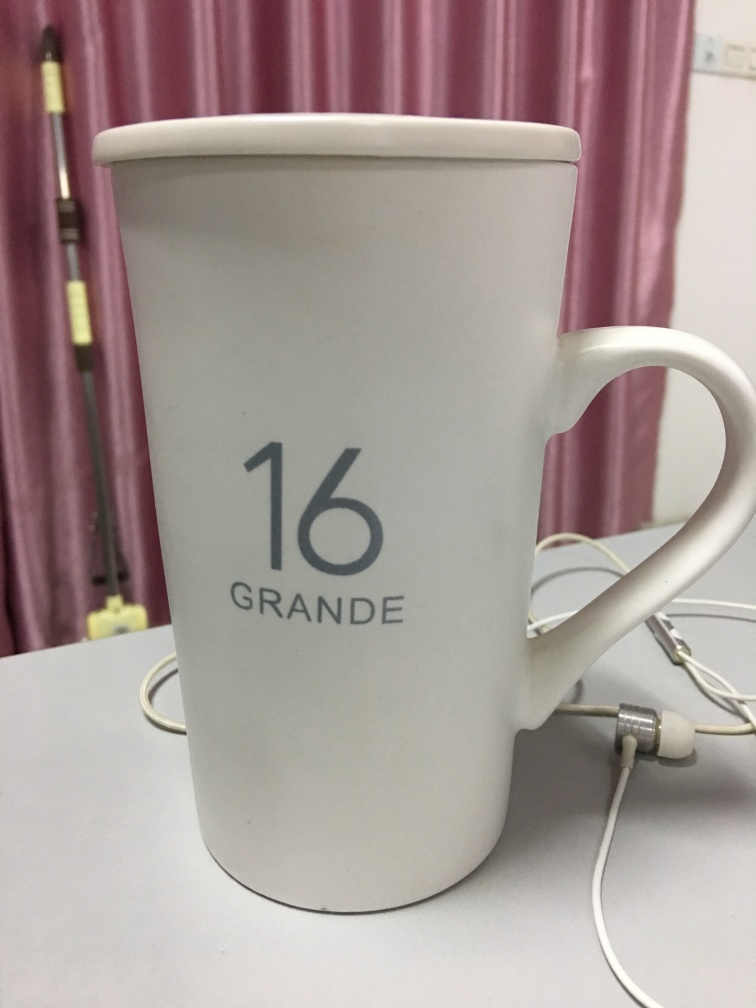Is the quality of this image relatively good? The quality of this image is quite acceptable as it appears sharp, with the object of interest - the mug - being clearly visible, including its details like the number '16' and the word 'GRANDE'. The lighting seems even and there's no noticeable distortion. However, there is a negligible lack of focus on the curtain and the wall, possibly due to a shallow depth of field, which is not critical for the image's main subject. 